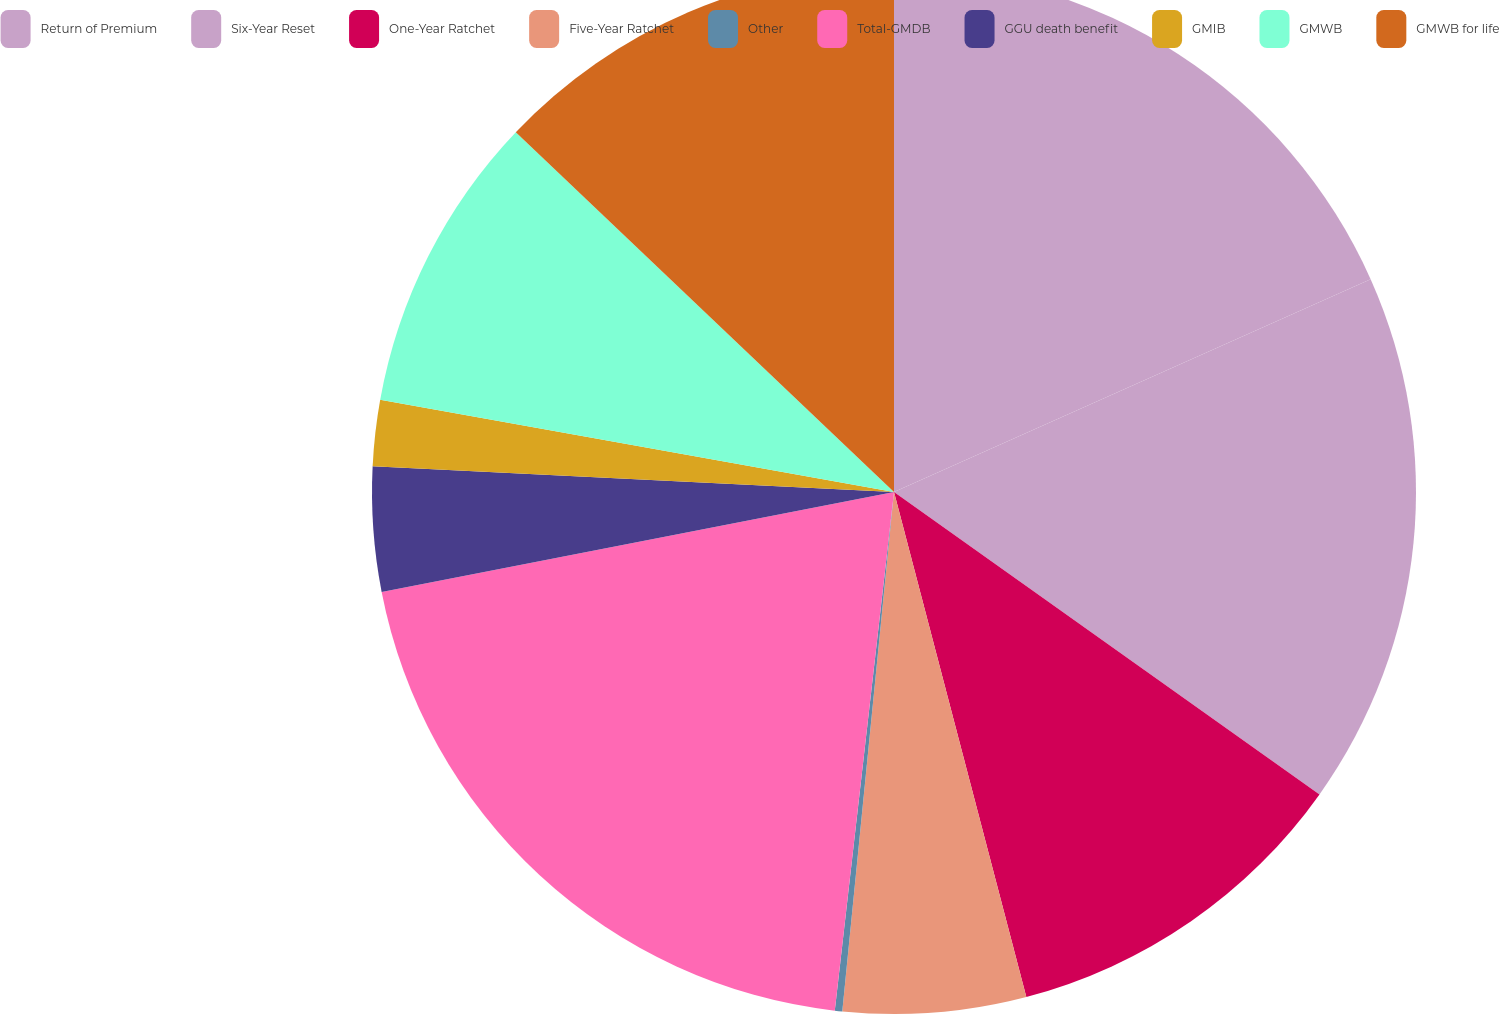<chart> <loc_0><loc_0><loc_500><loc_500><pie_chart><fcel>Return of Premium<fcel>Six-Year Reset<fcel>One-Year Ratchet<fcel>Five-Year Ratchet<fcel>Other<fcel>Total-GMDB<fcel>GGU death benefit<fcel>GMIB<fcel>GMWB<fcel>GMWB for life<nl><fcel>18.32%<fcel>16.52%<fcel>11.09%<fcel>5.66%<fcel>0.23%<fcel>20.13%<fcel>3.85%<fcel>2.04%<fcel>9.28%<fcel>12.9%<nl></chart> 